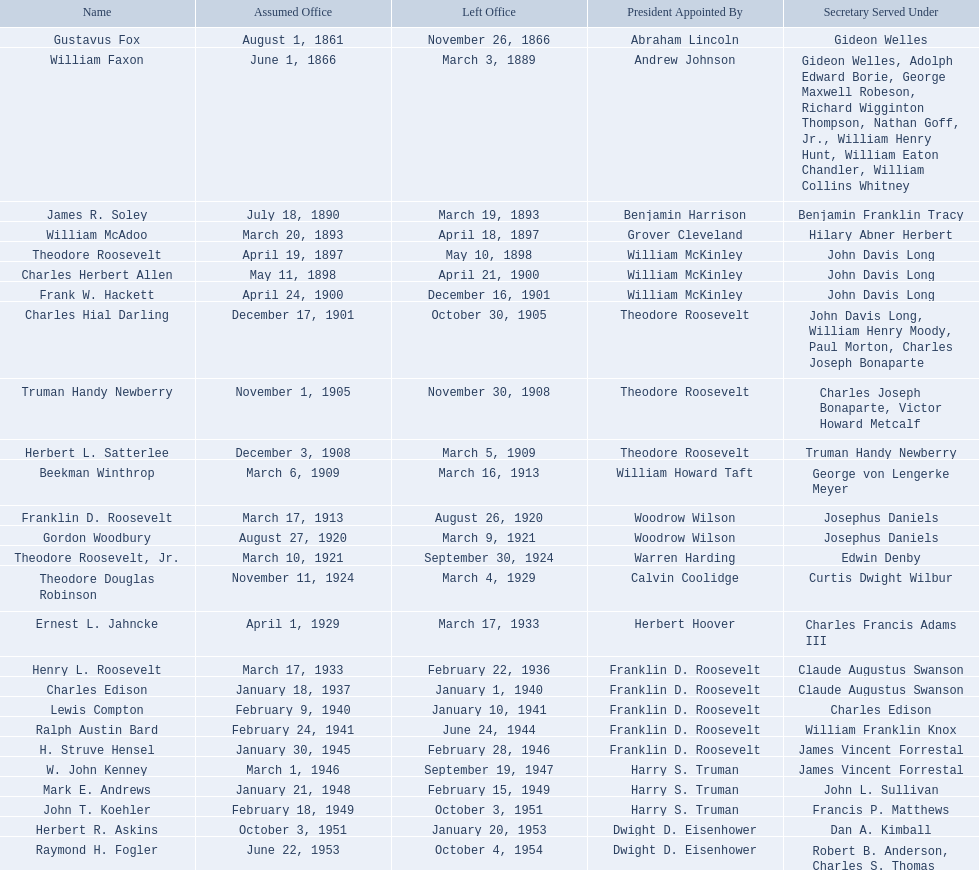What are all the designations? Gustavus Fox, William Faxon, James R. Soley, William McAdoo, Theodore Roosevelt, Charles Herbert Allen, Frank W. Hackett, Charles Hial Darling, Truman Handy Newberry, Herbert L. Satterlee, Beekman Winthrop, Franklin D. Roosevelt, Gordon Woodbury, Theodore Roosevelt, Jr., Theodore Douglas Robinson, Ernest L. Jahncke, Henry L. Roosevelt, Charles Edison, Lewis Compton, Ralph Austin Bard, H. Struve Hensel, W. John Kenney, Mark E. Andrews, John T. Koehler, Herbert R. Askins, Raymond H. Fogler. When did they conclude their term? November 26, 1866, March 3, 1889, March 19, 1893, April 18, 1897, May 10, 1898, April 21, 1900, December 16, 1901, October 30, 1905, November 30, 1908, March 5, 1909, March 16, 1913, August 26, 1920, March 9, 1921, September 30, 1924, March 4, 1929, March 17, 1933, February 22, 1936, January 1, 1940, January 10, 1941, June 24, 1944, February 28, 1946, September 19, 1947, February 15, 1949, October 3, 1951, January 20, 1953, October 4, 1954. And when did raymond h. fogler step down? October 4, 1954. Throughout the 20th century, who served as assistant secretaries of the navy? Charles Herbert Allen, Frank W. Hackett, Charles Hial Darling, Truman Handy Newberry, Herbert L. Satterlee, Beekman Winthrop, Franklin D. Roosevelt, Gordon Woodbury, Theodore Roosevelt, Jr., Theodore Douglas Robinson, Ernest L. Jahncke, Henry L. Roosevelt, Charles Edison, Lewis Compton, Ralph Austin Bard, H. Struve Hensel, W. John Kenney, Mark E. Andrews, John T. Koehler, Herbert R. Askins, Raymond H. Fogler. What was the appointment date of raymond h. fogler as assistant secretary of the navy? June 22, 1953. When did his tenure in that office conclude? October 4, 1954. 